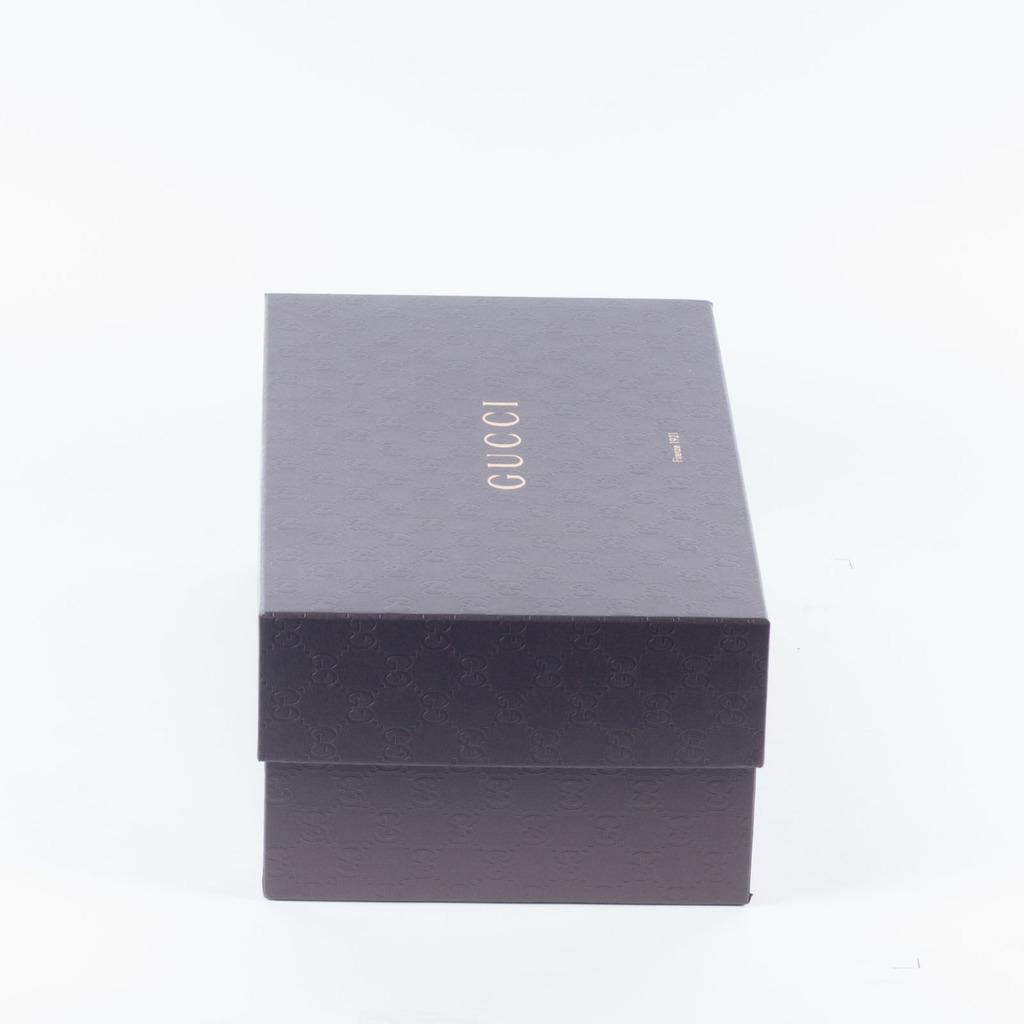<image>
Provide a brief description of the given image. A closed black box with Gucci written on the top. 